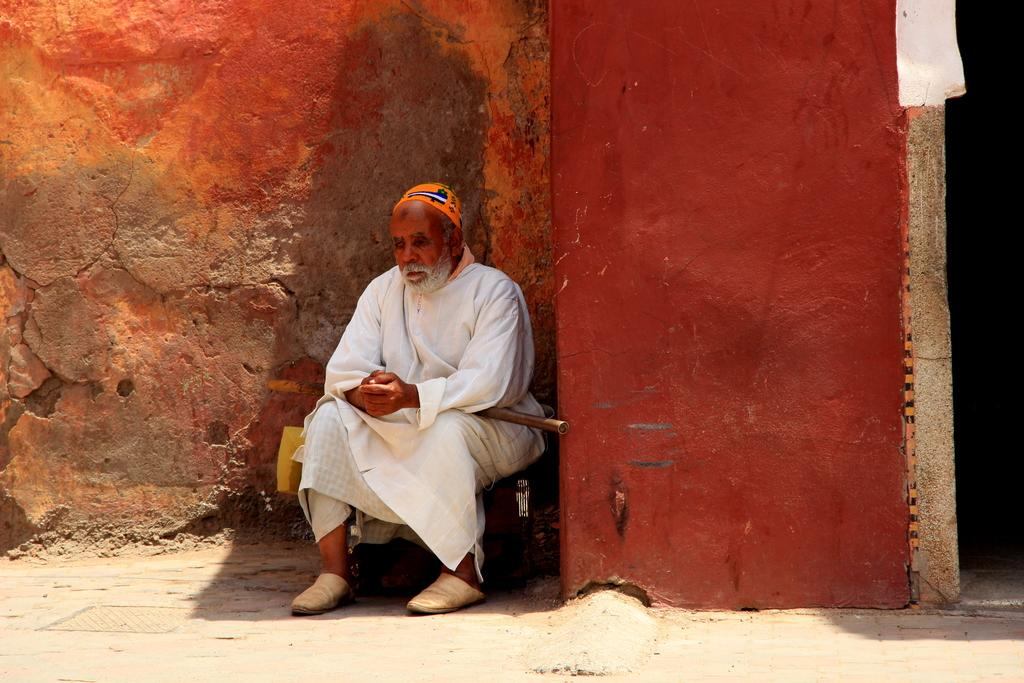What is the main subject of the image? There is a person in the image. What is the person wearing? The person is wearing a white dress and an orange cap. What is the person sitting on? The person is sitting on a bag. What can be seen in the background of the image? There is a red wall in the background of the image. How far away is the trade happening in the image? There is no mention of trade in the image, so it cannot be determined how far away it might be. 